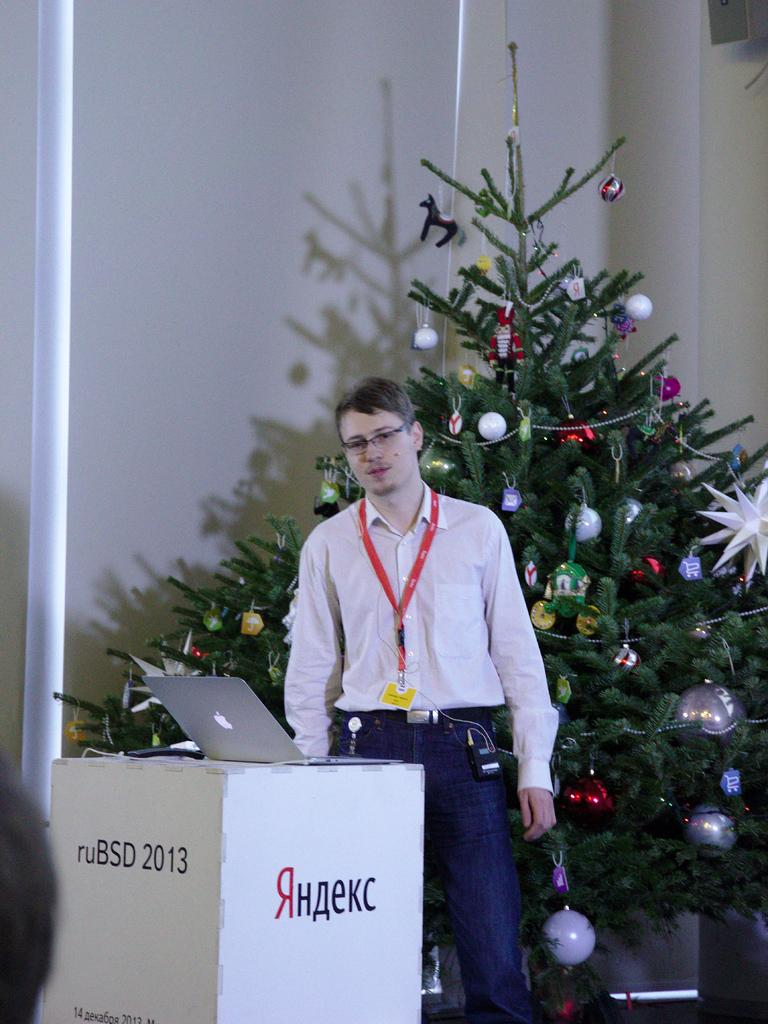<image>
Create a compact narrative representing the image presented. A man stands in front of a podium that says ruBSD 2013 and something in Russian on it. 